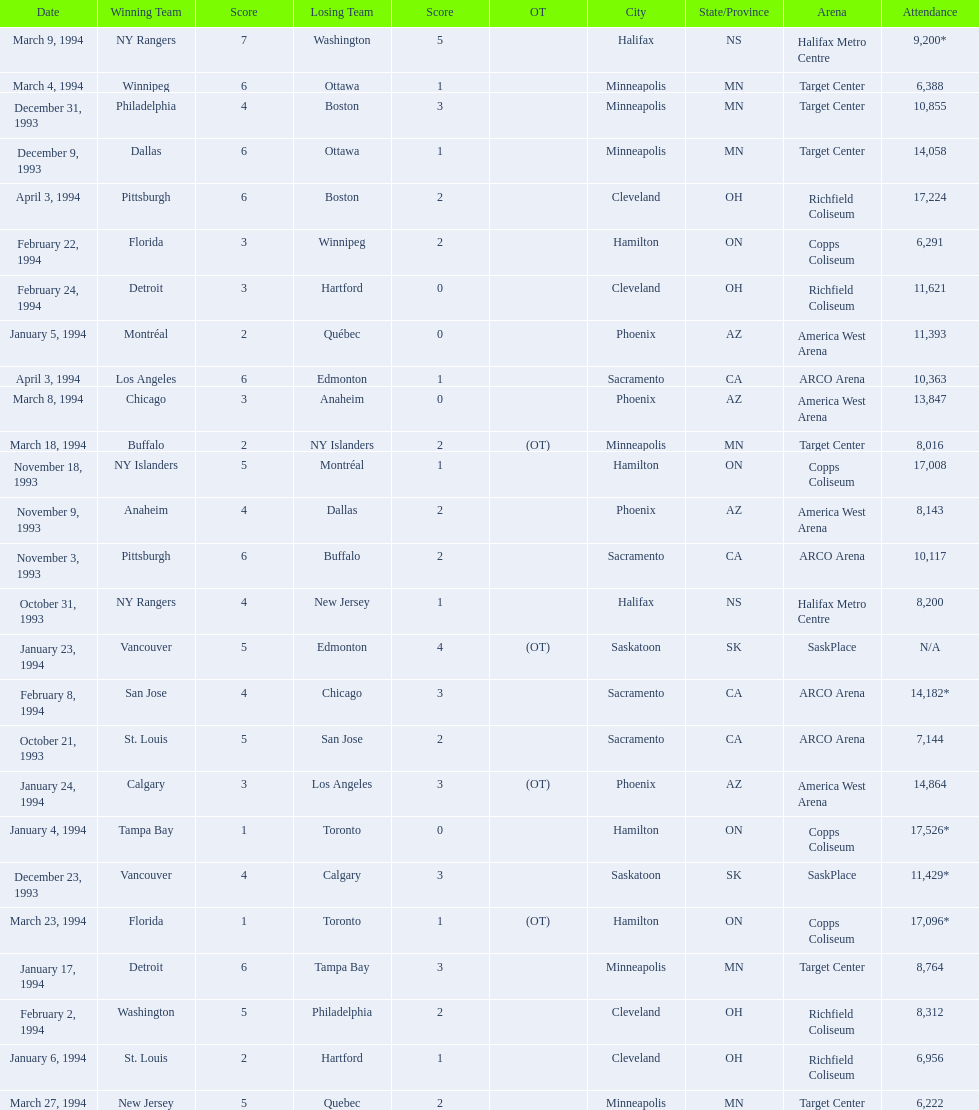What was the attendance on january 24, 1994? 14,864. What was the attendance on december 23, 1993? 11,429*. Between january 24, 1994 and december 23, 1993, which had the higher attendance? January 4, 1994. 